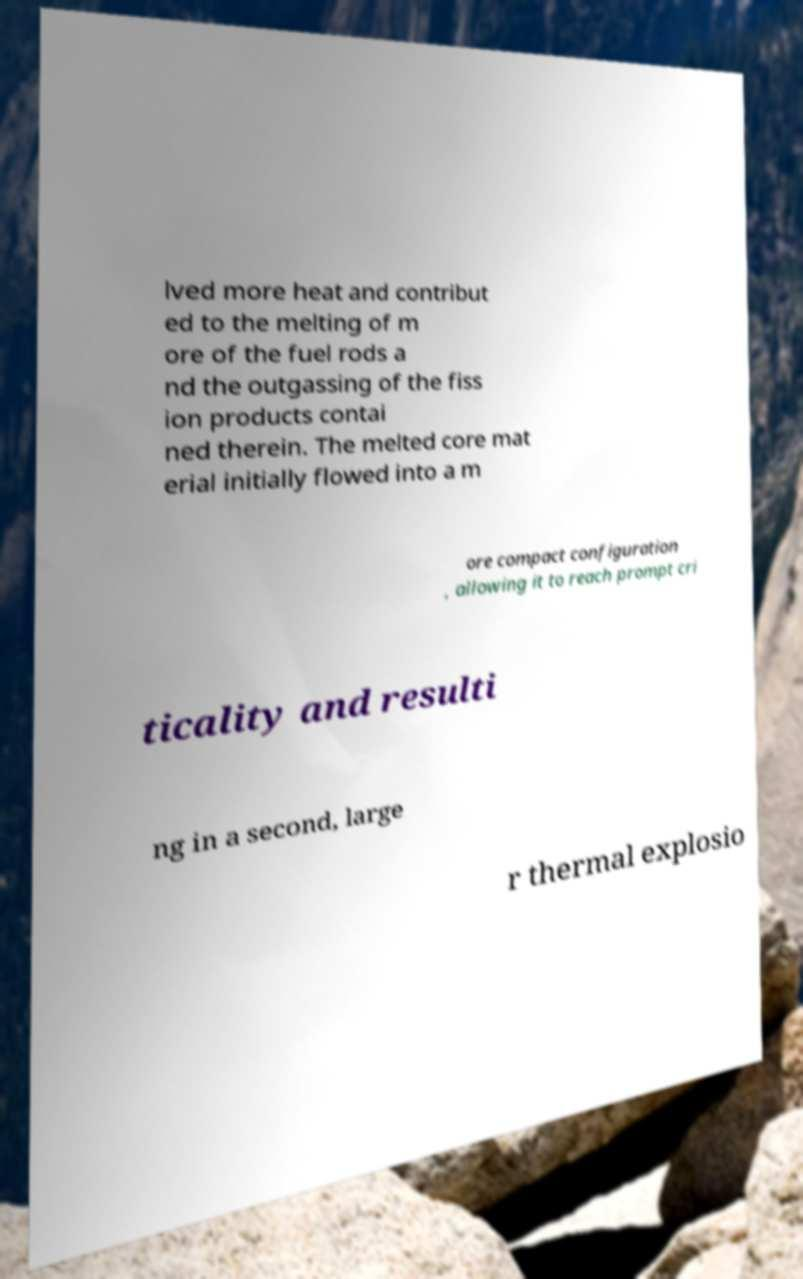Can you accurately transcribe the text from the provided image for me? lved more heat and contribut ed to the melting of m ore of the fuel rods a nd the outgassing of the fiss ion products contai ned therein. The melted core mat erial initially flowed into a m ore compact configuration , allowing it to reach prompt cri ticality and resulti ng in a second, large r thermal explosio 